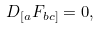Convert formula to latex. <formula><loc_0><loc_0><loc_500><loc_500>D _ { [ a } F _ { b c ] } = 0 ,</formula> 